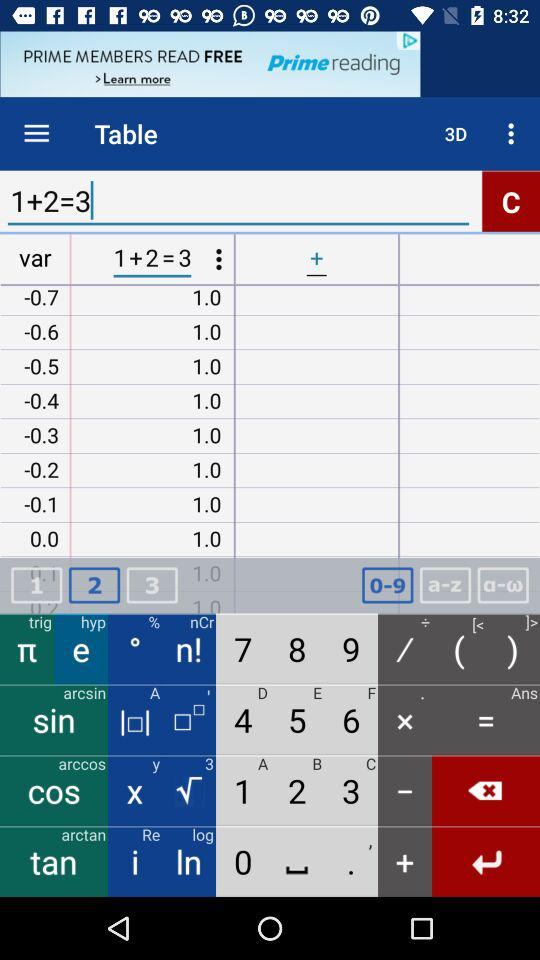What is the sum? The sum is 3. 